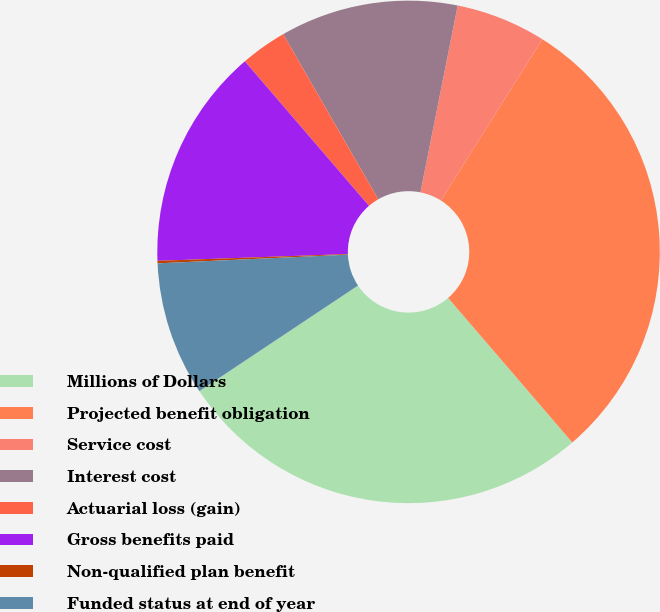Convert chart to OTSL. <chart><loc_0><loc_0><loc_500><loc_500><pie_chart><fcel>Millions of Dollars<fcel>Projected benefit obligation<fcel>Service cost<fcel>Interest cost<fcel>Actuarial loss (gain)<fcel>Gross benefits paid<fcel>Non-qualified plan benefit<fcel>Funded status at end of year<nl><fcel>26.95%<fcel>29.77%<fcel>5.8%<fcel>11.45%<fcel>2.98%<fcel>14.27%<fcel>0.16%<fcel>8.62%<nl></chart> 